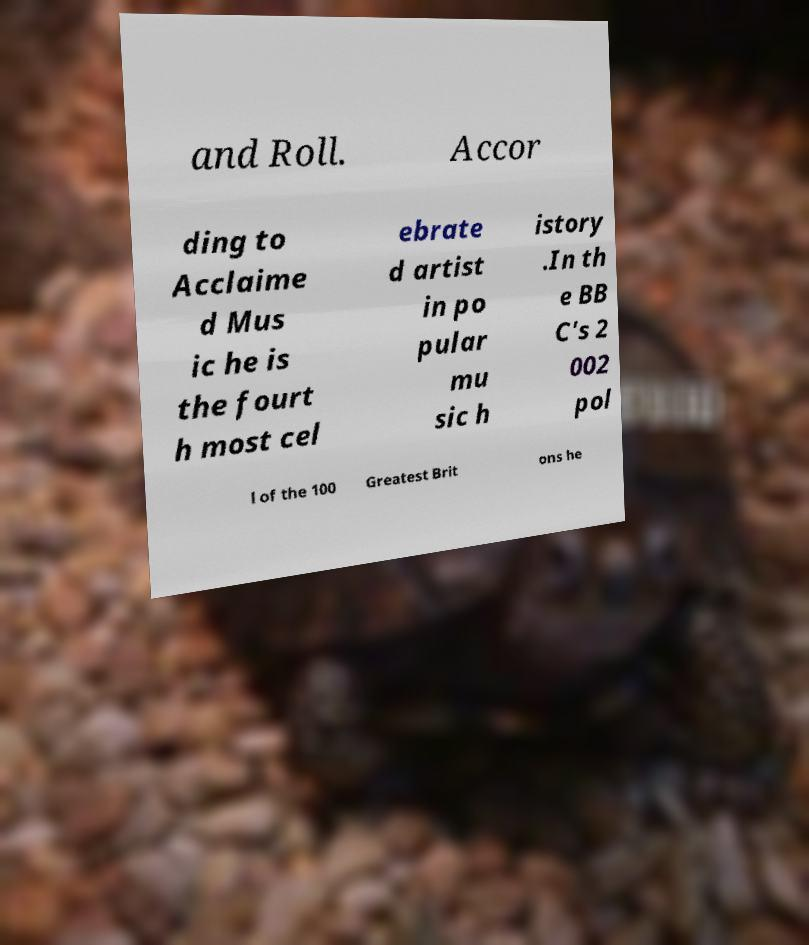I need the written content from this picture converted into text. Can you do that? and Roll. Accor ding to Acclaime d Mus ic he is the fourt h most cel ebrate d artist in po pular mu sic h istory .In th e BB C's 2 002 pol l of the 100 Greatest Brit ons he 